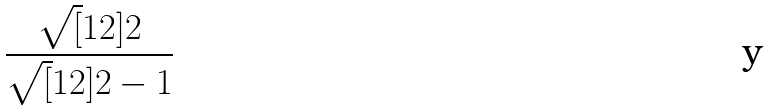Convert formula to latex. <formula><loc_0><loc_0><loc_500><loc_500>\frac { \sqrt { [ } 1 2 ] { 2 } } { \sqrt { [ } 1 2 ] { 2 } - 1 }</formula> 